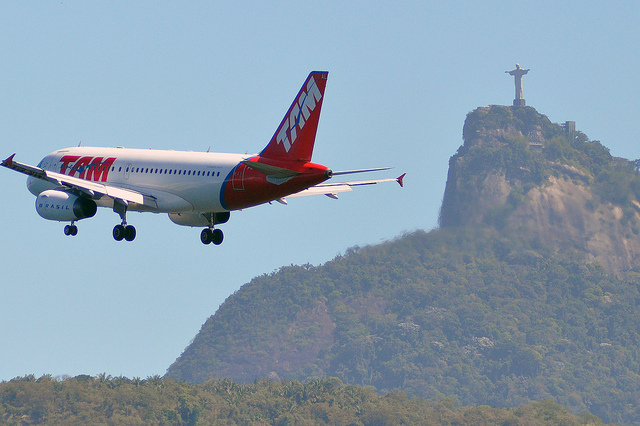Considering world knowledge, can you explain the significance of the statue in the background? Yes, the statue in the background is Christ the Redeemer, a globally recognized symbol of Rio de Janeiro and Brazil. It stands atop the Corcovado mountain overlooking the city and is one of the New Seven Wonders of the World. This statue is a significant symbol of Christianity and a major pilgrimage site for Christians. Additionally, it is a key tourist attraction, offering panoramic views of Rio de Janeiro and surrounding landscapes. 